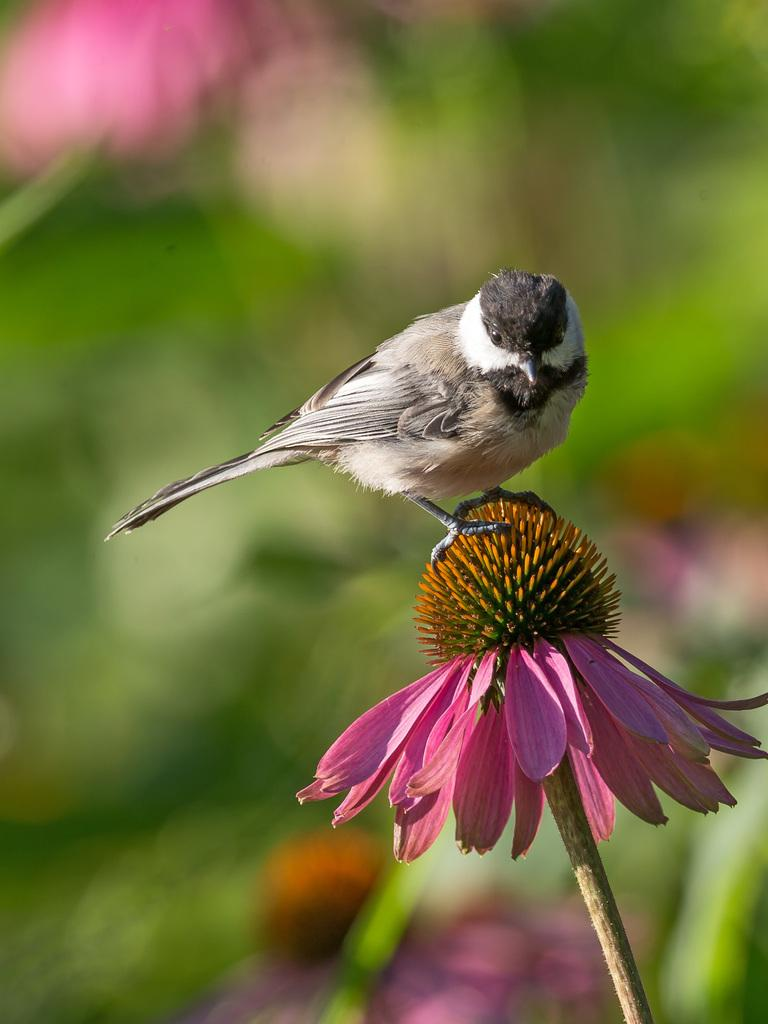What type of animal is in the image? There is a bird in the image. Where is the bird located? The bird is on a flower. What else can be seen in the background of the image? There are flowers visible in the background of the image. What type of cup is being used to hold the bird in the image? There is no cup present in the image; the bird is on a flower. 